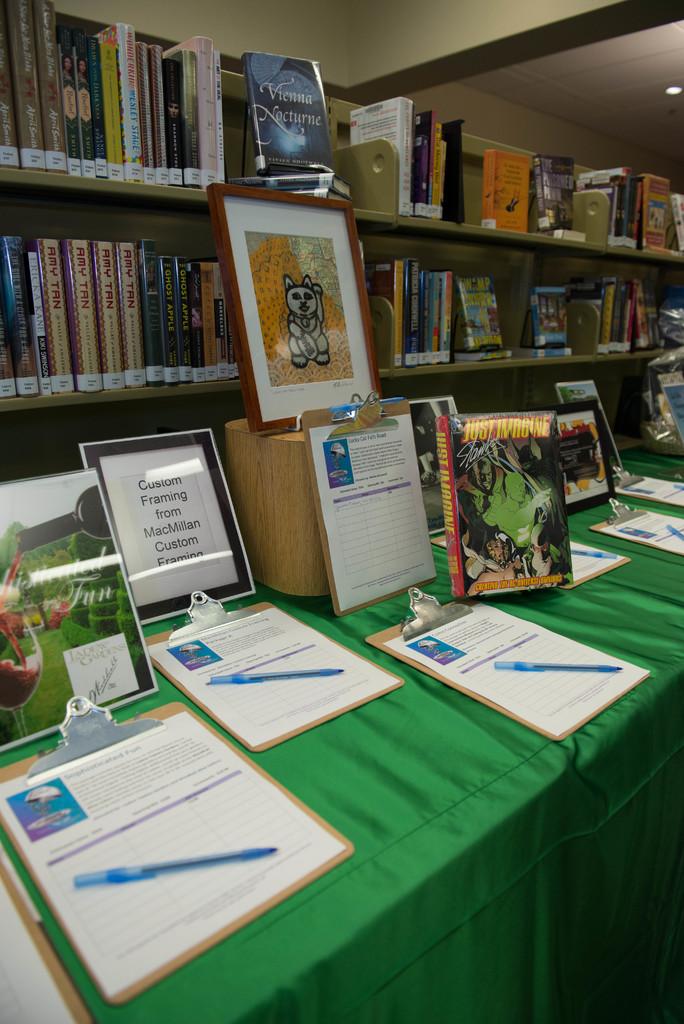What is the title of the book above the kitten painting?
Make the answer very short. Vienna nocturne. 